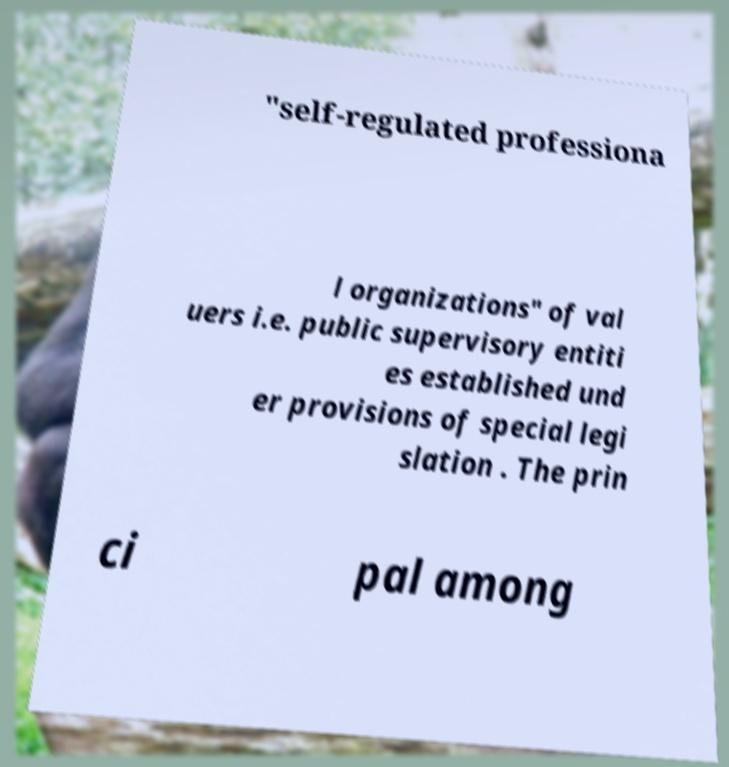Can you accurately transcribe the text from the provided image for me? "self-regulated professiona l organizations" of val uers i.e. public supervisory entiti es established und er provisions of special legi slation . The prin ci pal among 